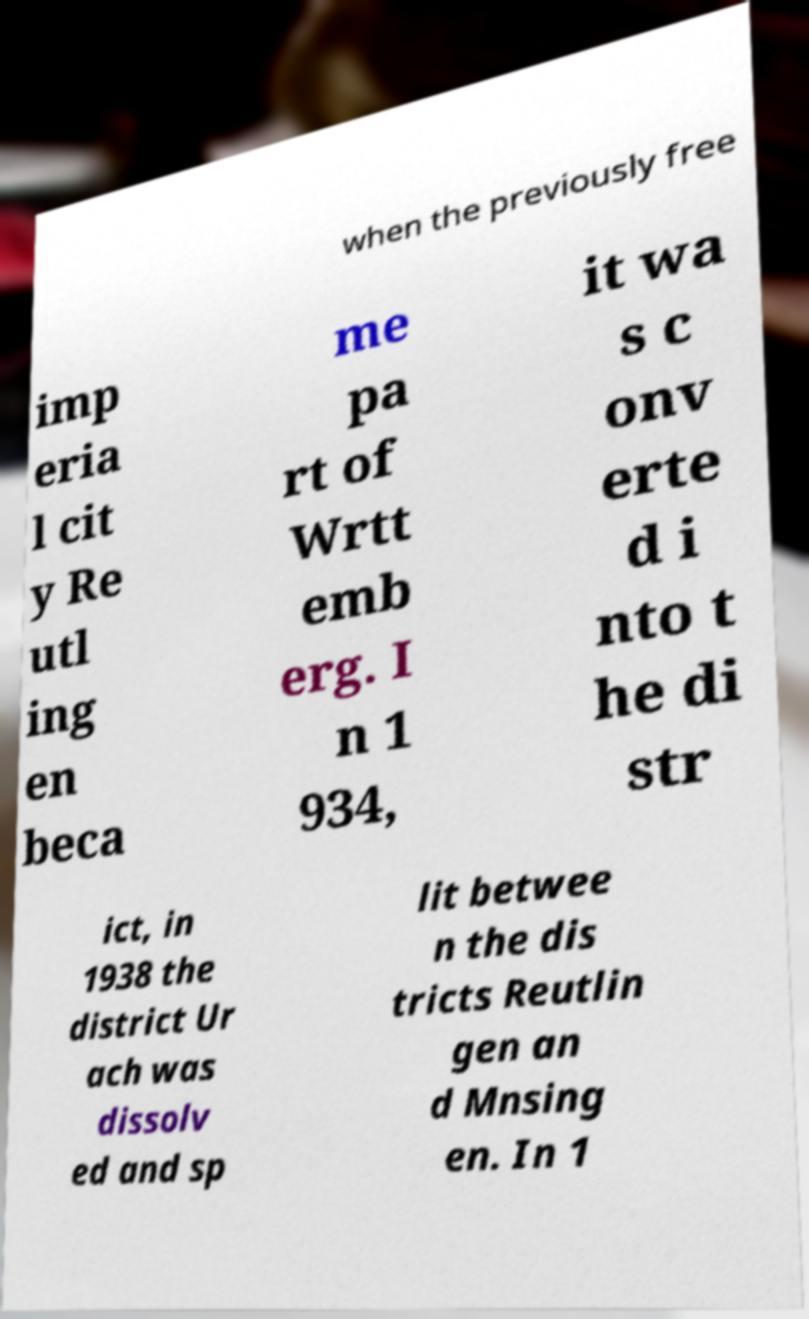For documentation purposes, I need the text within this image transcribed. Could you provide that? when the previously free imp eria l cit y Re utl ing en beca me pa rt of Wrtt emb erg. I n 1 934, it wa s c onv erte d i nto t he di str ict, in 1938 the district Ur ach was dissolv ed and sp lit betwee n the dis tricts Reutlin gen an d Mnsing en. In 1 